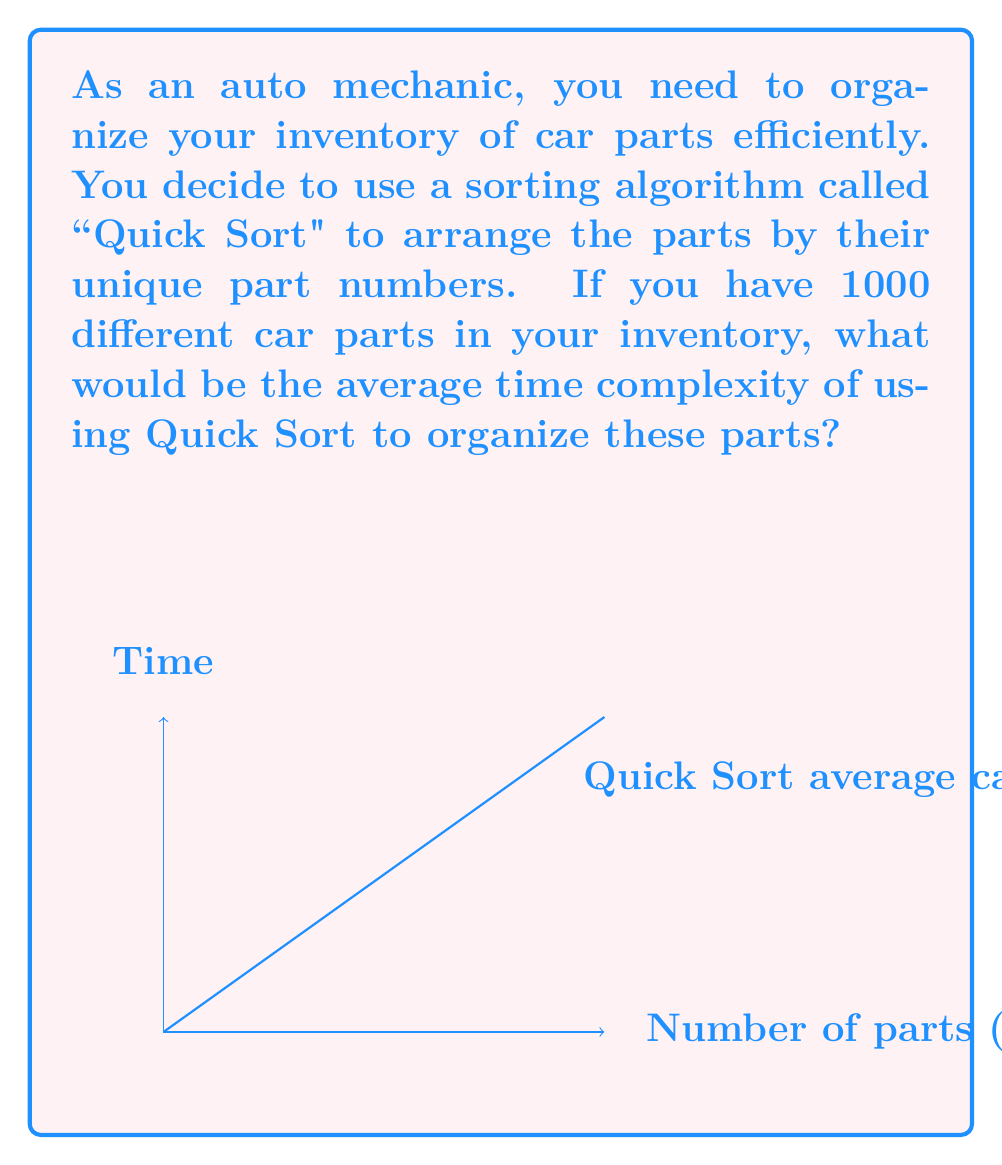Help me with this question. To determine the average time complexity of Quick Sort for organizing 1000 car parts, let's follow these steps:

1) Quick Sort's average time complexity is generally expressed as $O(n \log n)$, where $n$ is the number of items to be sorted.

2) In this case, $n = 1000$ (the number of car parts).

3) To calculate the time complexity:
   
   $T(n) = n \log n$
   
   $T(1000) = 1000 \log 1000$

4) Using the properties of logarithms:
   
   $\log 1000 = \log (10^3) = 3 \log 10 \approx 3 \times 2.303 \approx 6.91$

5) Therefore:
   
   $T(1000) = 1000 \times 6.91 = 6910$

6) This means that the algorithm will perform approximately 6910 operations on average to sort 1000 car parts.

7) However, when expressing time complexity, we typically use Big O notation and ignore constants. So we would still express this as $O(n \log n)$.
Answer: $O(n \log n)$ 